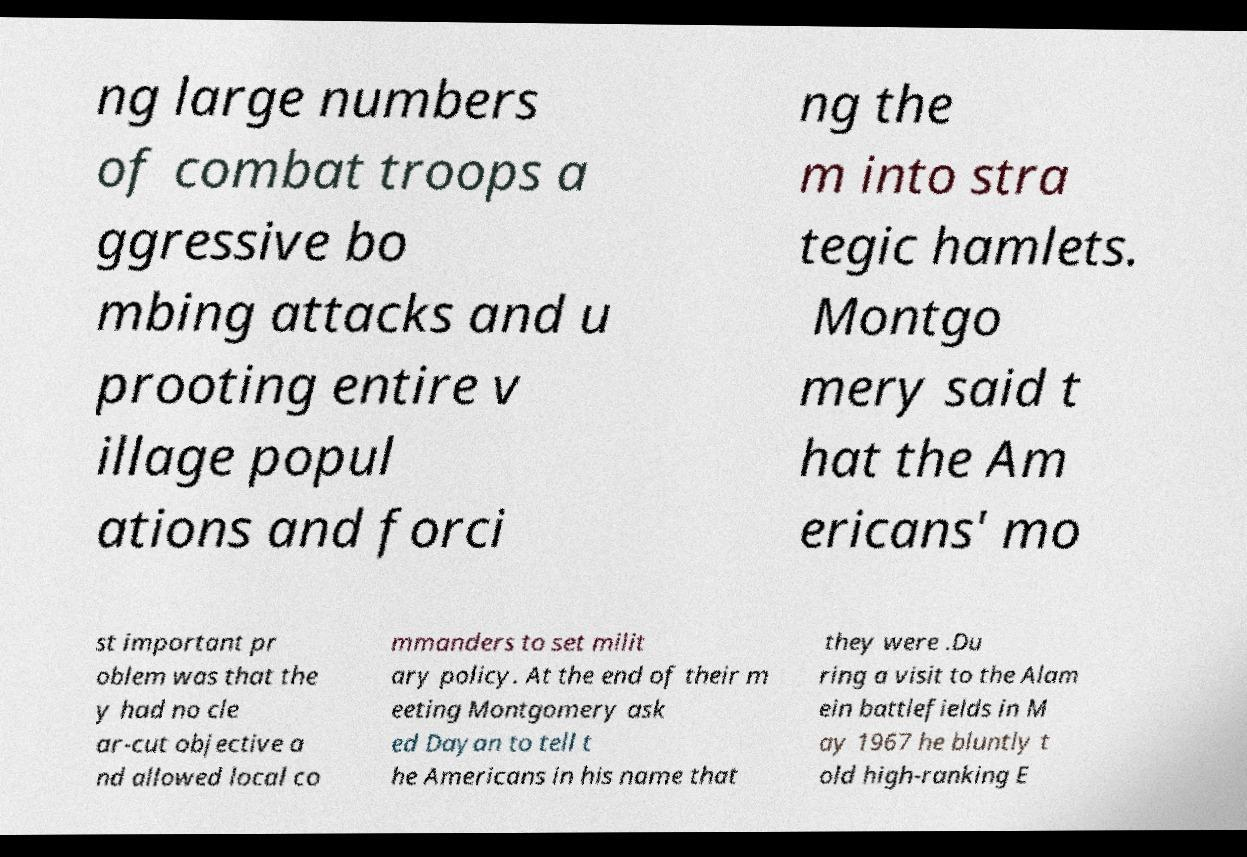I need the written content from this picture converted into text. Can you do that? ng large numbers of combat troops a ggressive bo mbing attacks and u prooting entire v illage popul ations and forci ng the m into stra tegic hamlets. Montgo mery said t hat the Am ericans' mo st important pr oblem was that the y had no cle ar-cut objective a nd allowed local co mmanders to set milit ary policy. At the end of their m eeting Montgomery ask ed Dayan to tell t he Americans in his name that they were .Du ring a visit to the Alam ein battlefields in M ay 1967 he bluntly t old high-ranking E 